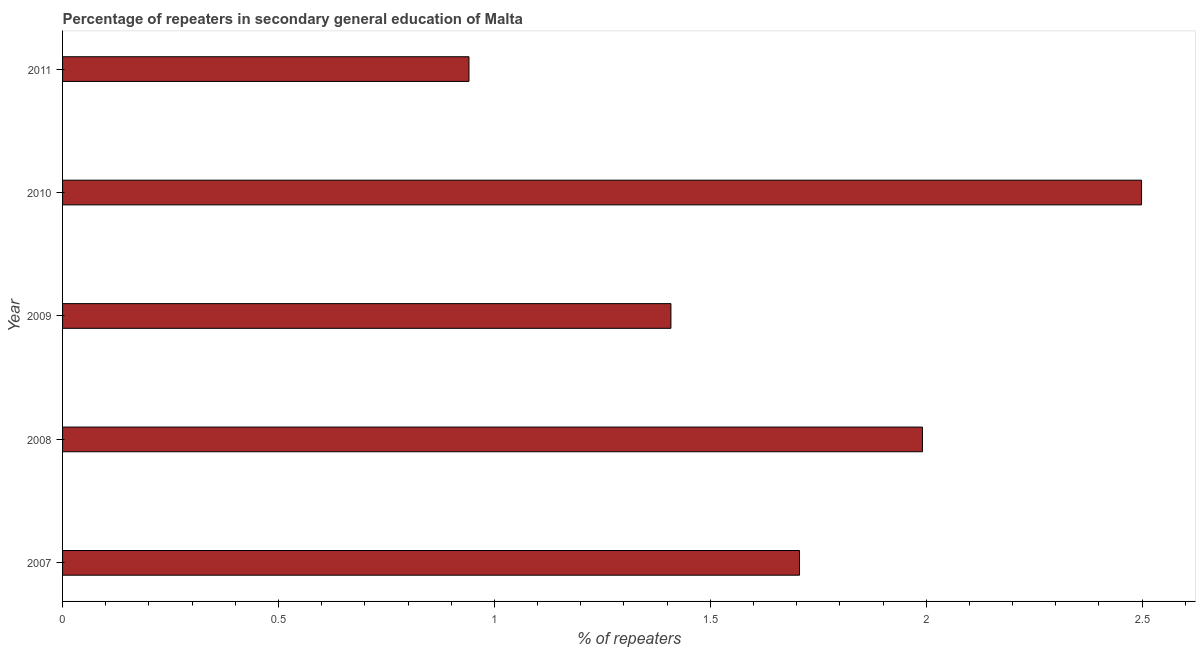Does the graph contain any zero values?
Keep it short and to the point. No. What is the title of the graph?
Offer a very short reply. Percentage of repeaters in secondary general education of Malta. What is the label or title of the X-axis?
Provide a short and direct response. % of repeaters. What is the percentage of repeaters in 2010?
Offer a very short reply. 2.5. Across all years, what is the maximum percentage of repeaters?
Offer a terse response. 2.5. Across all years, what is the minimum percentage of repeaters?
Make the answer very short. 0.94. In which year was the percentage of repeaters maximum?
Your answer should be compact. 2010. What is the sum of the percentage of repeaters?
Provide a short and direct response. 8.55. What is the difference between the percentage of repeaters in 2008 and 2009?
Provide a short and direct response. 0.58. What is the average percentage of repeaters per year?
Offer a very short reply. 1.71. What is the median percentage of repeaters?
Your answer should be very brief. 1.71. Do a majority of the years between 2009 and 2011 (inclusive) have percentage of repeaters greater than 0.9 %?
Give a very brief answer. Yes. What is the ratio of the percentage of repeaters in 2007 to that in 2008?
Provide a short and direct response. 0.86. Is the percentage of repeaters in 2007 less than that in 2010?
Provide a short and direct response. Yes. What is the difference between the highest and the second highest percentage of repeaters?
Give a very brief answer. 0.51. Is the sum of the percentage of repeaters in 2008 and 2009 greater than the maximum percentage of repeaters across all years?
Provide a short and direct response. Yes. What is the difference between the highest and the lowest percentage of repeaters?
Your answer should be very brief. 1.56. How many years are there in the graph?
Ensure brevity in your answer.  5. What is the % of repeaters of 2007?
Keep it short and to the point. 1.71. What is the % of repeaters of 2008?
Keep it short and to the point. 1.99. What is the % of repeaters in 2009?
Offer a very short reply. 1.41. What is the % of repeaters of 2010?
Make the answer very short. 2.5. What is the % of repeaters of 2011?
Offer a very short reply. 0.94. What is the difference between the % of repeaters in 2007 and 2008?
Offer a terse response. -0.28. What is the difference between the % of repeaters in 2007 and 2009?
Your response must be concise. 0.3. What is the difference between the % of repeaters in 2007 and 2010?
Make the answer very short. -0.79. What is the difference between the % of repeaters in 2007 and 2011?
Provide a succinct answer. 0.77. What is the difference between the % of repeaters in 2008 and 2009?
Your response must be concise. 0.58. What is the difference between the % of repeaters in 2008 and 2010?
Offer a very short reply. -0.51. What is the difference between the % of repeaters in 2008 and 2011?
Your answer should be compact. 1.05. What is the difference between the % of repeaters in 2009 and 2010?
Give a very brief answer. -1.09. What is the difference between the % of repeaters in 2009 and 2011?
Provide a succinct answer. 0.47. What is the difference between the % of repeaters in 2010 and 2011?
Keep it short and to the point. 1.56. What is the ratio of the % of repeaters in 2007 to that in 2008?
Your answer should be very brief. 0.86. What is the ratio of the % of repeaters in 2007 to that in 2009?
Make the answer very short. 1.21. What is the ratio of the % of repeaters in 2007 to that in 2010?
Your answer should be compact. 0.68. What is the ratio of the % of repeaters in 2007 to that in 2011?
Give a very brief answer. 1.81. What is the ratio of the % of repeaters in 2008 to that in 2009?
Provide a succinct answer. 1.41. What is the ratio of the % of repeaters in 2008 to that in 2010?
Provide a succinct answer. 0.8. What is the ratio of the % of repeaters in 2008 to that in 2011?
Ensure brevity in your answer.  2.12. What is the ratio of the % of repeaters in 2009 to that in 2010?
Provide a short and direct response. 0.56. What is the ratio of the % of repeaters in 2009 to that in 2011?
Offer a terse response. 1.5. What is the ratio of the % of repeaters in 2010 to that in 2011?
Keep it short and to the point. 2.65. 